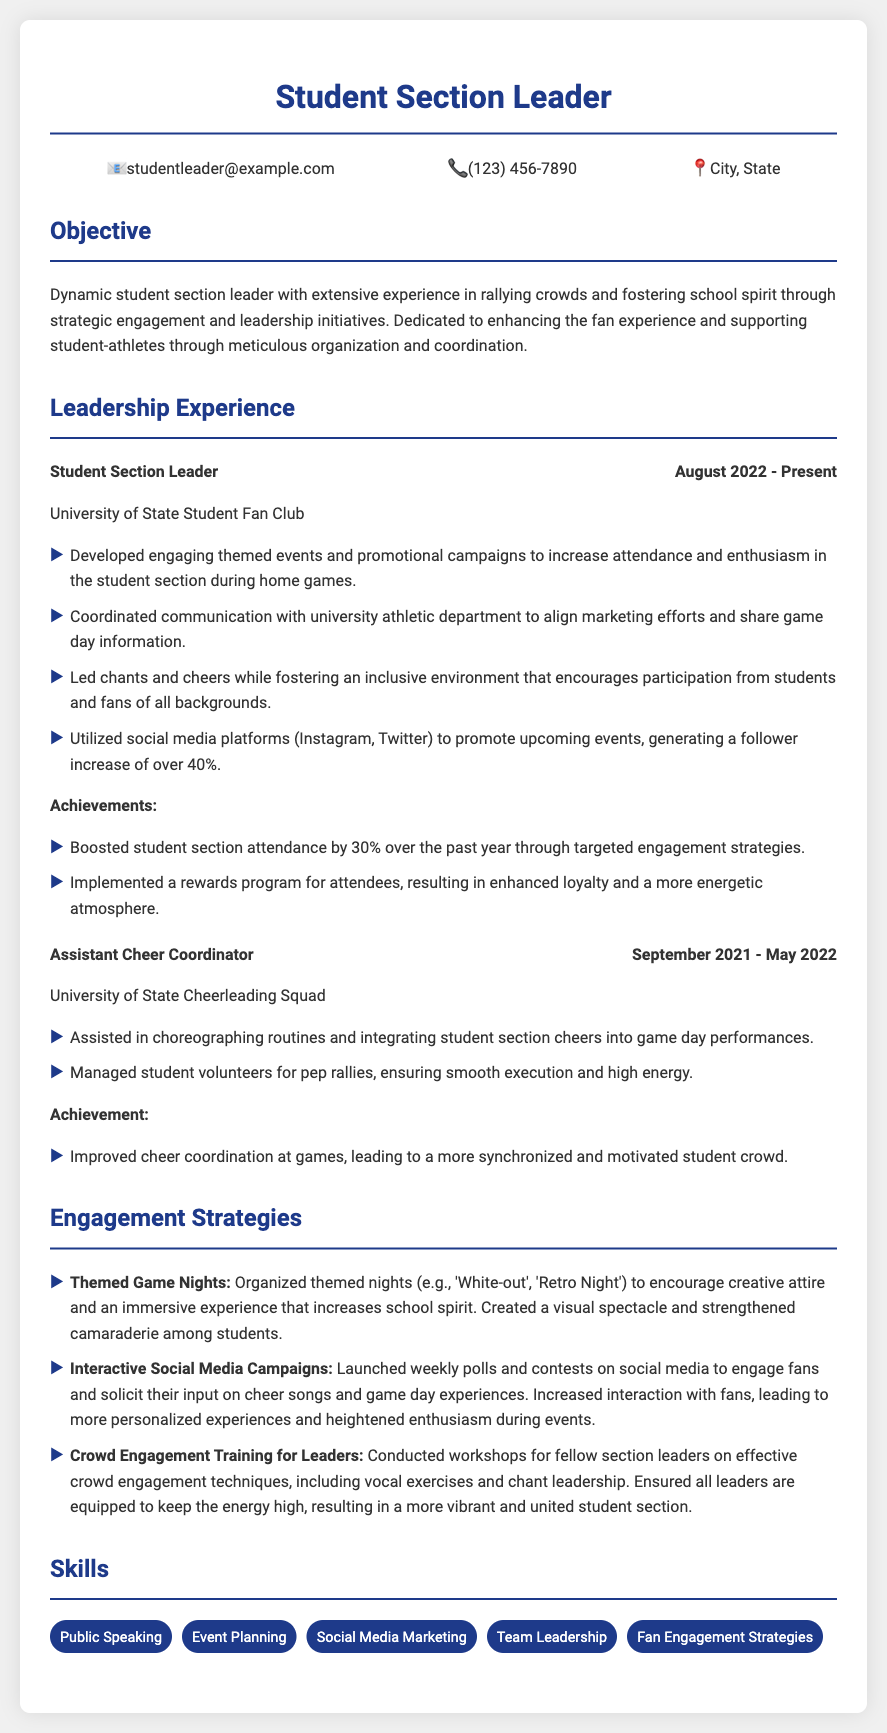What is the current position held? The position listed in the document is the current role specified under Leadership Experience.
Answer: Student Section Leader When did the individual start their leadership role? The document states the start date of the current leadership role under Leadership Experience.
Answer: August 2022 What university is mentioned in the CV? The university name is provided in the context of both positions held.
Answer: University of State What percentage increase in attendance is noted? The document mentions the specific percentage increase in attendance due to engagement strategies.
Answer: 30% What was the role prior to the current position? The document lists the previous position held just before the current one.
Answer: Assistant Cheer Coordinator What engagement strategy involves social media? The document specifies a strategy that uses social media for fan engagement.
Answer: Interactive Social Media Campaigns How many skills are listed under skills? The document notes the total number of skills listed in that section.
Answer: Five What type of events were organized for engagement strategies? The document describes a specific style of events aimed at boosting engagement.
Answer: Themed Game Nights What reward program was implemented? The document mentions a specific program aimed at enhancing loyalty and atmosphere.
Answer: Rewards program for attendees 